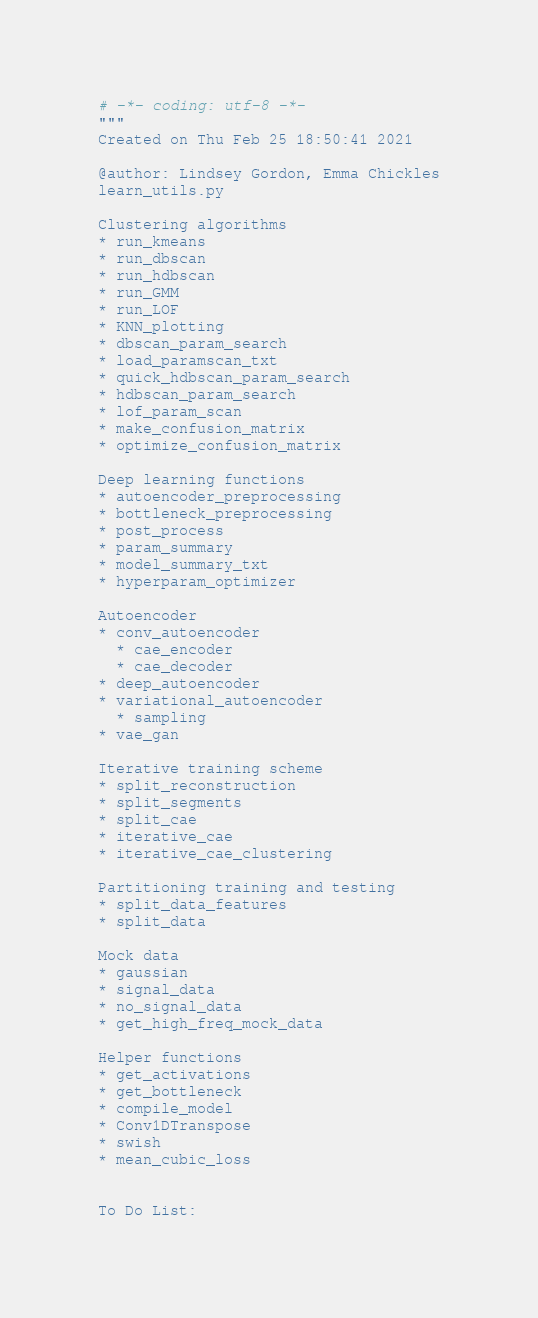Convert code to text. <code><loc_0><loc_0><loc_500><loc_500><_Python_># -*- coding: utf-8 -*-
"""
Created on Thu Feb 25 18:50:41 2021

@author: Lindsey Gordon, Emma Chickles
learn_utils.py

Clustering algorithms
* run_kmeans
* run_dbscan
* run_hdbscan
* run_GMM
* run_LOF
* KNN_plotting
* dbscan_param_search
* load_paramscan_txt
* quick_hdbscan_param_search
* hdbscan_param_search
* lof_param_scan
* make_confusion_matrix
* optimize_confusion_matrix

Deep learning functions
* autoencoder_preprocessing
* bottleneck_preprocessing
* post_process
* param_summary
* model_summary_txt
* hyperparam_optimizer

Autoencoder
* conv_autoencoder
  * cae_encoder
  * cae_decoder
* deep_autoencoder
* variational_autoencoder
  * sampling
* vae_gan

Iterative training scheme
* split_reconstruction
* split_segments
* split_cae
* iterative_cae
* iterative_cae_clustering

Partitioning training and testing
* split_data_features
* split_data

Mock data
* gaussian
* signal_data
* no_signal_data
* get_high_freq_mock_data

Helper functions
* get_activations
* get_bottleneck
* compile_model
* Conv1DTranspose
* swish
* mean_cubic_loss


To Do List: </code> 